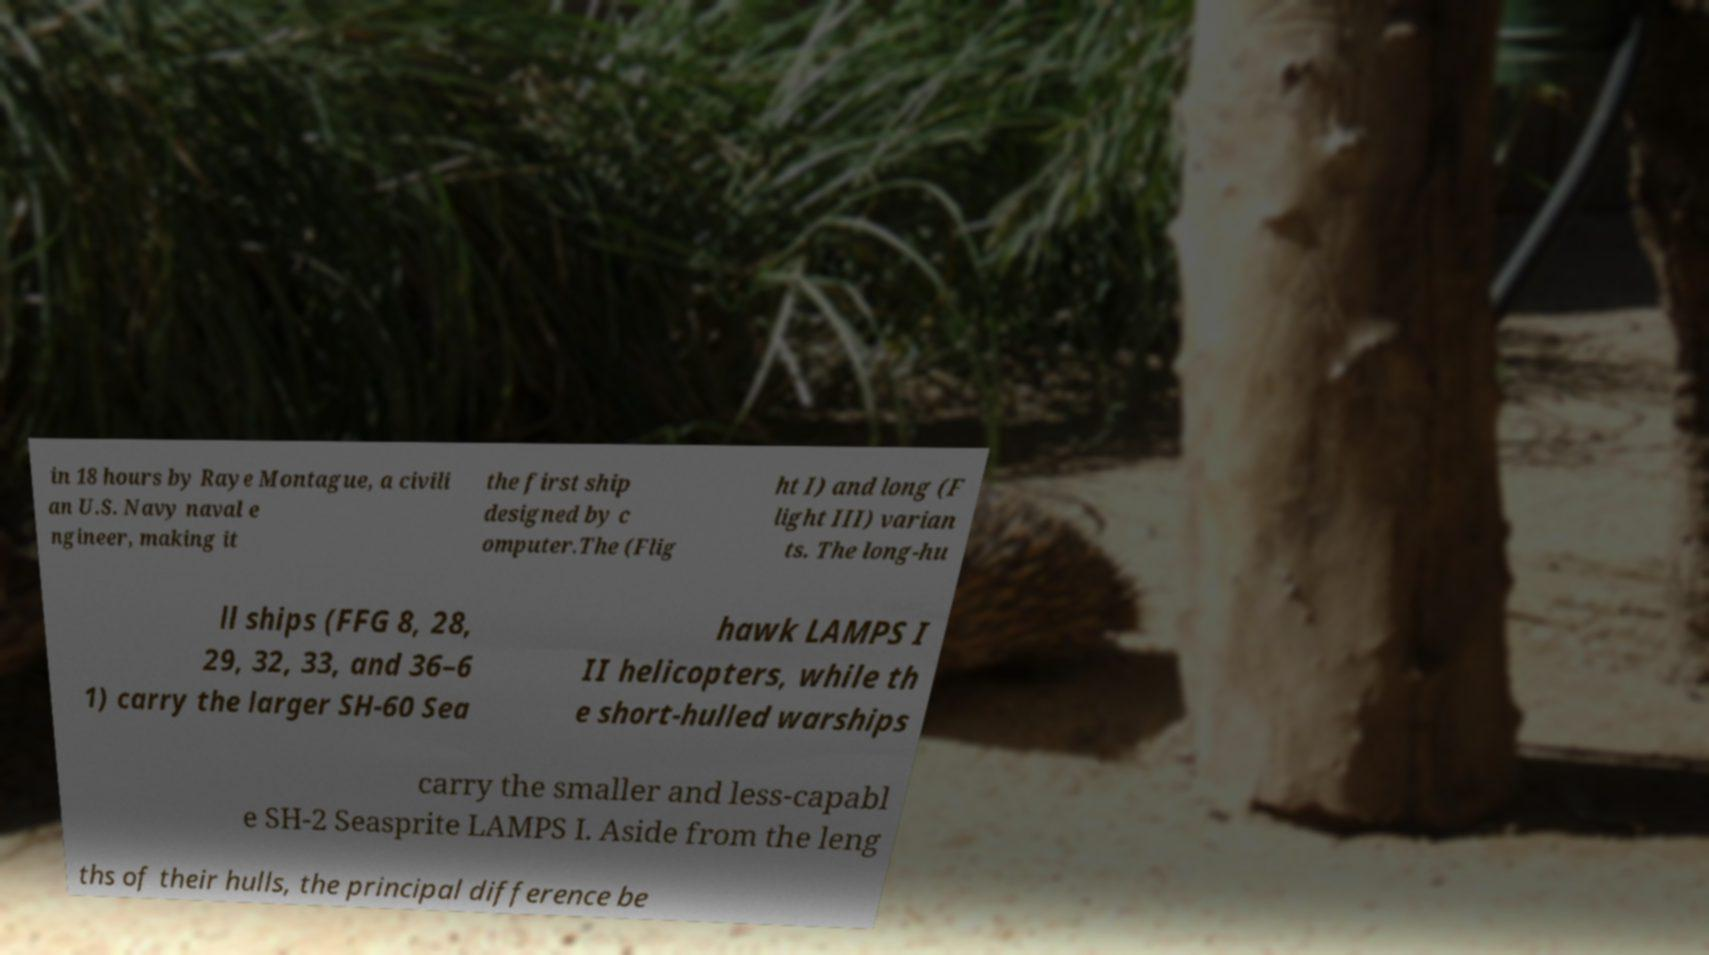For documentation purposes, I need the text within this image transcribed. Could you provide that? in 18 hours by Raye Montague, a civili an U.S. Navy naval e ngineer, making it the first ship designed by c omputer.The (Flig ht I) and long (F light III) varian ts. The long-hu ll ships (FFG 8, 28, 29, 32, 33, and 36–6 1) carry the larger SH-60 Sea hawk LAMPS I II helicopters, while th e short-hulled warships carry the smaller and less-capabl e SH-2 Seasprite LAMPS I. Aside from the leng ths of their hulls, the principal difference be 